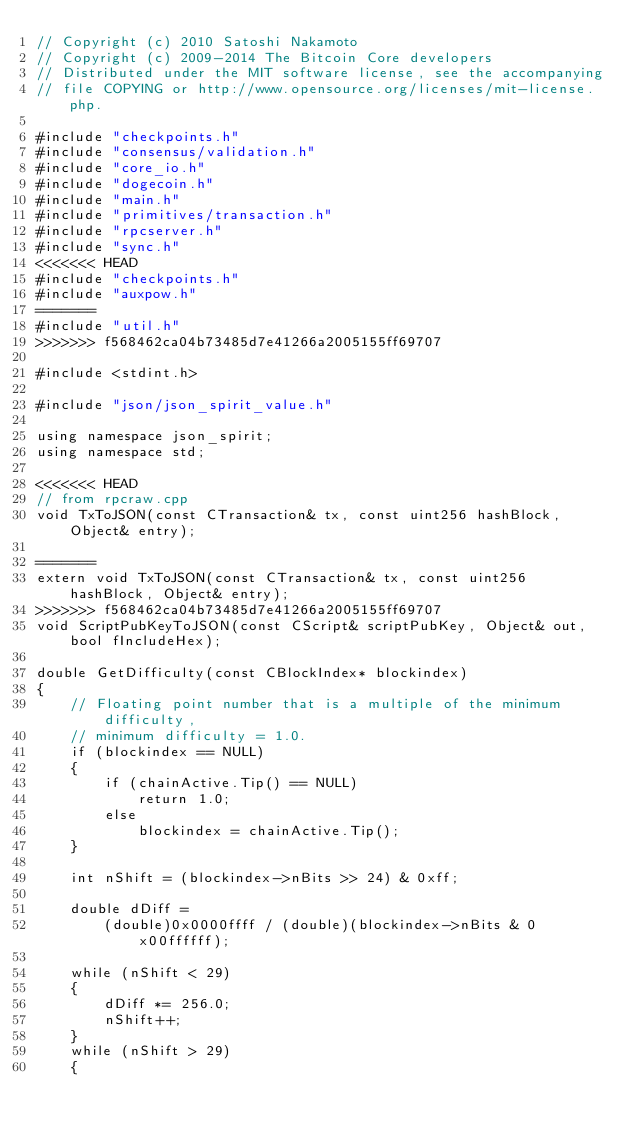<code> <loc_0><loc_0><loc_500><loc_500><_C++_>// Copyright (c) 2010 Satoshi Nakamoto
// Copyright (c) 2009-2014 The Bitcoin Core developers
// Distributed under the MIT software license, see the accompanying
// file COPYING or http://www.opensource.org/licenses/mit-license.php.

#include "checkpoints.h"
#include "consensus/validation.h"
#include "core_io.h"
#include "dogecoin.h"
#include "main.h"
#include "primitives/transaction.h"
#include "rpcserver.h"
#include "sync.h"
<<<<<<< HEAD
#include "checkpoints.h"
#include "auxpow.h"
=======
#include "util.h"
>>>>>>> f568462ca04b73485d7e41266a2005155ff69707

#include <stdint.h>

#include "json/json_spirit_value.h"

using namespace json_spirit;
using namespace std;

<<<<<<< HEAD
// from rpcraw.cpp
void TxToJSON(const CTransaction& tx, const uint256 hashBlock, Object& entry);

=======
extern void TxToJSON(const CTransaction& tx, const uint256 hashBlock, Object& entry);
>>>>>>> f568462ca04b73485d7e41266a2005155ff69707
void ScriptPubKeyToJSON(const CScript& scriptPubKey, Object& out, bool fIncludeHex);

double GetDifficulty(const CBlockIndex* blockindex)
{
    // Floating point number that is a multiple of the minimum difficulty,
    // minimum difficulty = 1.0.
    if (blockindex == NULL)
    {
        if (chainActive.Tip() == NULL)
            return 1.0;
        else
            blockindex = chainActive.Tip();
    }

    int nShift = (blockindex->nBits >> 24) & 0xff;

    double dDiff =
        (double)0x0000ffff / (double)(blockindex->nBits & 0x00ffffff);

    while (nShift < 29)
    {
        dDiff *= 256.0;
        nShift++;
    }
    while (nShift > 29)
    {</code> 